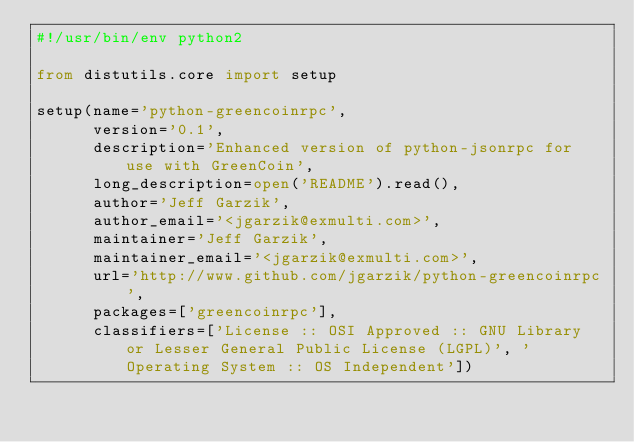<code> <loc_0><loc_0><loc_500><loc_500><_Python_>#!/usr/bin/env python2

from distutils.core import setup

setup(name='python-greencoinrpc',
      version='0.1',
      description='Enhanced version of python-jsonrpc for use with GreenCoin',
      long_description=open('README').read(),
      author='Jeff Garzik',
      author_email='<jgarzik@exmulti.com>',
      maintainer='Jeff Garzik',
      maintainer_email='<jgarzik@exmulti.com>',
      url='http://www.github.com/jgarzik/python-greencoinrpc',
      packages=['greencoinrpc'],
      classifiers=['License :: OSI Approved :: GNU Library or Lesser General Public License (LGPL)', 'Operating System :: OS Independent'])
</code> 